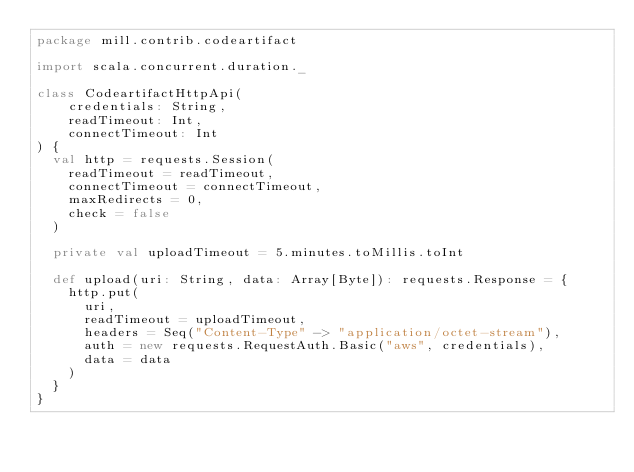Convert code to text. <code><loc_0><loc_0><loc_500><loc_500><_Scala_>package mill.contrib.codeartifact

import scala.concurrent.duration._

class CodeartifactHttpApi(
    credentials: String,
    readTimeout: Int,
    connectTimeout: Int
) {
  val http = requests.Session(
    readTimeout = readTimeout,
    connectTimeout = connectTimeout,
    maxRedirects = 0,
    check = false
  )

  private val uploadTimeout = 5.minutes.toMillis.toInt

  def upload(uri: String, data: Array[Byte]): requests.Response = {
    http.put(
      uri,
      readTimeout = uploadTimeout,
      headers = Seq("Content-Type" -> "application/octet-stream"),
      auth = new requests.RequestAuth.Basic("aws", credentials),
      data = data
    )
  }
}
</code> 